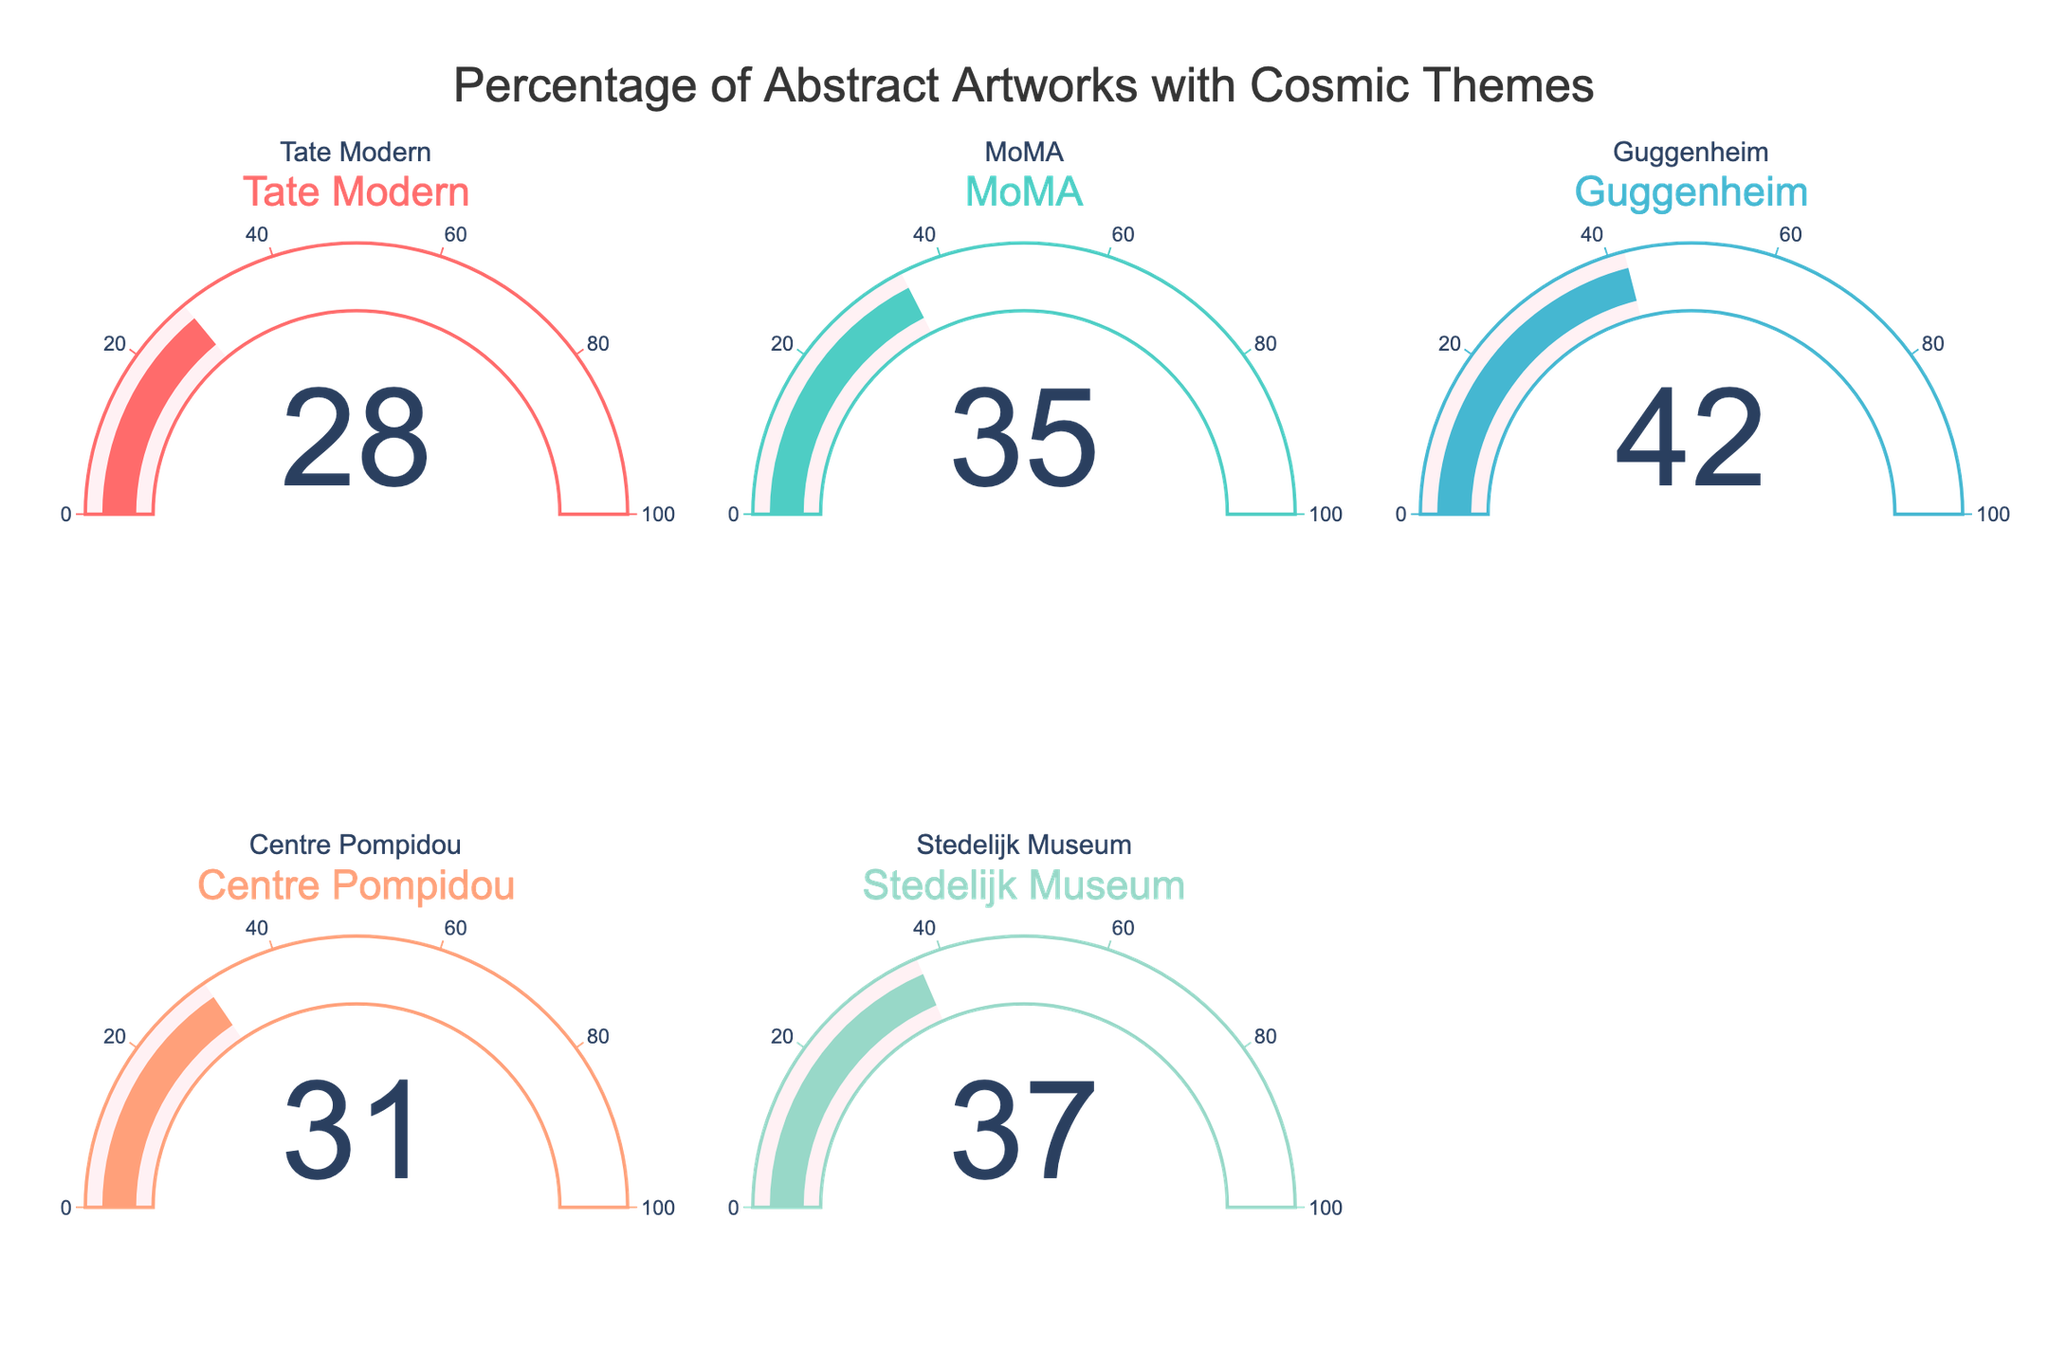what is the title of the figure? The title is positioned at the top center of the figure. From the visual, it's clear that the title reads "Percentage of Abstract Artworks with Cosmic Themes."
Answer: Percentage of Abstract Artworks with Cosmic Themes How many museums are represented in the figure? By counting the number of gauge charts shown in the figure, we can determine how many museums are represented. There are five gauge charts, each showing a different museum.
Answer: Five Which museum has the highest percentage of abstract artworks featuring cosmic themes? By observing the values displayed in the gauge charts, the Guggenheim has the highest percentage value which is 42.
Answer: Guggenheim What is the combined percentage of the Tate Modern and MoMA? The values for the Tate Modern and MoMA are 28 and 35 respectively. Summing these values gives 28 + 35 = 63.
Answer: 63 Which museum has a lower percentage of abstract artworks featuring cosmic themes than the Stedelijk Museum? Stedelijk Museum shows a percentage of 37. All museums with percentages lower than this are Tate Modern (28), Centre Pompidou (31).
Answer: Tate Modern, Centre Pompidou What is the average percentage of abstract artworks featuring cosmic themes across these museums? Sum the percentages of all represented museums: 28 (Tate Modern) + 35 (MoMA) + 42 (Guggenheim) + 31 (Centre Pompidou) + 37 (Stedelijk Museum) = 173. Divide by the number of museums: 173 / 5 = 34.6.
Answer: 34.6 By how much does the Guggenheim's percentage exceed the Centre Pompidou's? The Guggenheim has 42 and the Centre Pompidou has 31. Subtracting these gives 42 - 31 = 11.
Answer: 11 Which museum(s) have a percentage of abstract artworks featuring cosmic themes above 30%? By examining the gauge charts, the museums with percentages above 30% are MoMA (35), Guggenheim (42), Centre Pompidou (31), and Stedelijk Museum (37).
Answer: MoMA, Guggenheim, Centre Pompidou, Stedelijk Museum 